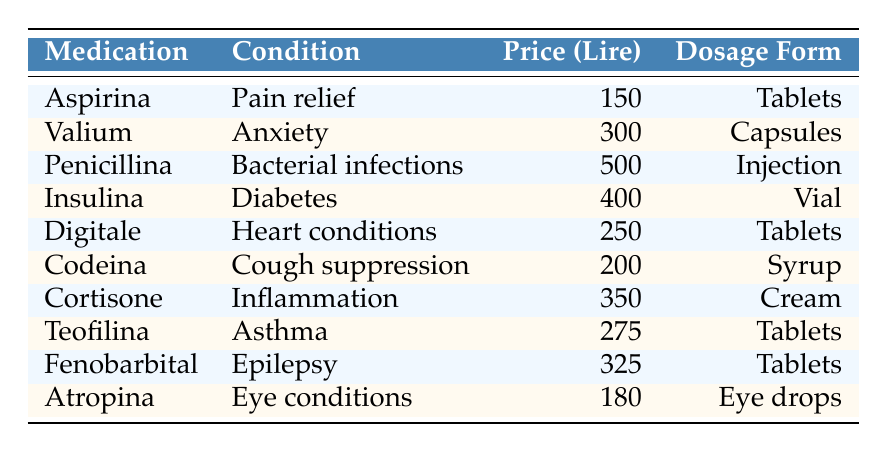What is the price of Aspirina? The table lists the price of Aspirina in the "Price (Lire)" column, which shows it is priced at 150 Lire.
Answer: 150 Which medication is used for anxiety? Referring to the "Condition" column, Valium is specifically listed as the medication for anxiety.
Answer: Valium What is the dosage form of Insulina? The table states that the dosage form of Insulina is provided in a "Vial" as indicated in the "Dosage Form" column.
Answer: Vial Is Codeina used for treating bacterial infections? Codeina is listed for "Cough suppression," while Penicillina is the medication for "Bacterial infections." Therefore, the answer is no.
Answer: No What is the total price of Aspirina and Atropina? To find the total price, add the price of Aspirina (150 Lire) and the price of Atropina (180 Lire): 150 + 180 = 330 Lire.
Answer: 330 Which medication has the highest price, and what is that price? Looking through the "Price (Lire)" column, Penicillina is the medication with the highest price at 500 Lire.
Answer: Penicillina, 500 How much more expensive is Cortisone compared to Digitale? The price of Cortisone is 350 Lire and Digitale is 250 Lire. Subtract Digitale's price from Cortisone's price: 350 - 250 = 100 Lire.
Answer: 100 What is the average price of all medications listed in the table? To find the average, first sum all the prices: 150 + 300 + 500 + 400 + 250 + 200 + 350 + 275 + 325 + 180 = 2930 Lire. There are 10 medications, so divide the total by 10: 2930 / 10 = 293 Lire.
Answer: 293 Are there any medications listed that are delivered as injections? The table shows Penicillina is delivered in "Injection" form, confirming the existence of a medication for this method.
Answer: Yes Which medication is priced below 200 Lire? By checking the "Price (Lire)" column, only Aspirina (150 Lire) and Atropina (180 Lire) are below 200 Lire.
Answer: Aspirina, Atropina 